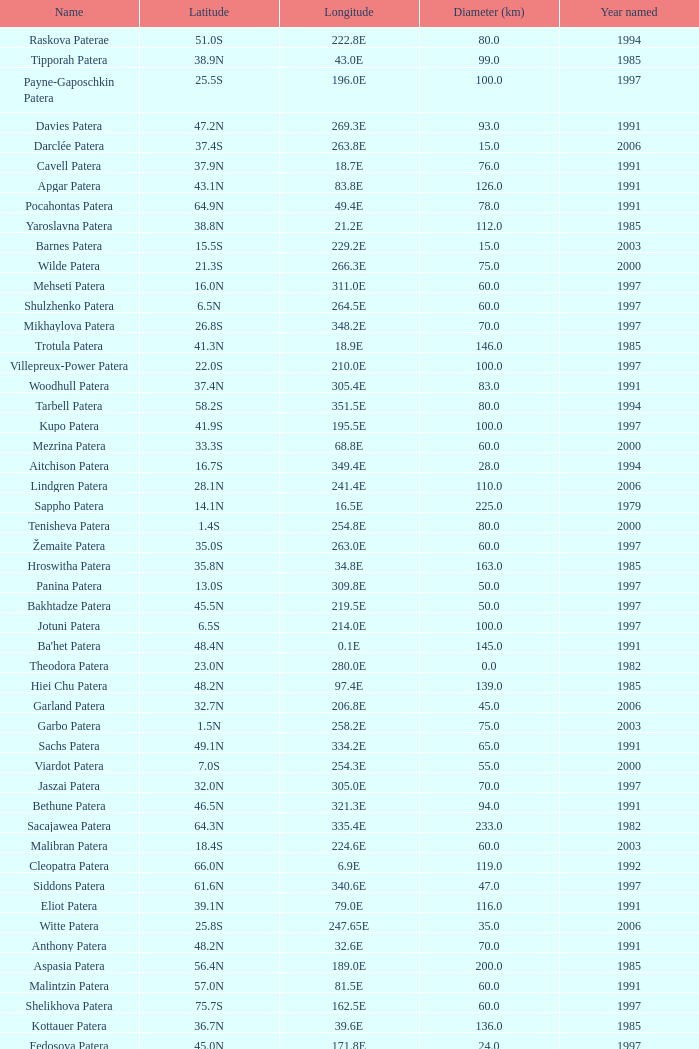What is the average Year Named, when Latitude is 37.9N, and when Diameter (km) is greater than 76? None. 